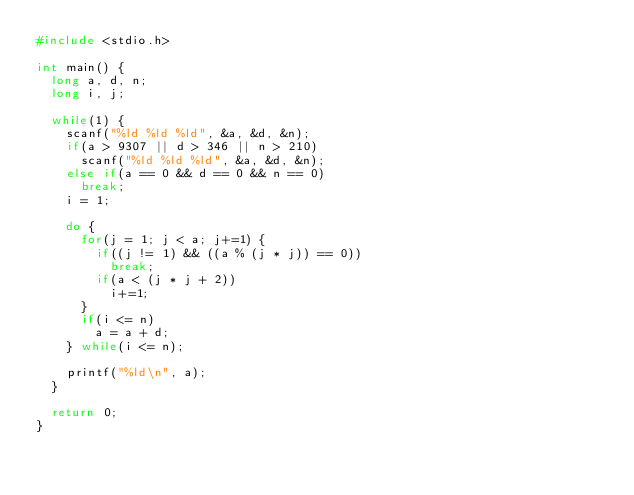Convert code to text. <code><loc_0><loc_0><loc_500><loc_500><_C_>#include <stdio.h>

int main() {
  long a, d, n;
  long i, j;

  while(1) {
    scanf("%ld %ld %ld", &a, &d, &n);
    if(a > 9307 || d > 346 || n > 210)
      scanf("%ld %ld %ld", &a, &d, &n);
    else if(a == 0 && d == 0 && n == 0)
      break;
    i = 1;

    do {
      for(j = 1; j < a; j+=1) {
        if((j != 1) && ((a % (j * j)) == 0))
          break;
        if(a < (j * j + 2))
          i+=1;
      }
      if(i <= n)
        a = a + d;
    } while(i <= n);

    printf("%ld\n", a);
  }

  return 0;
}</code> 